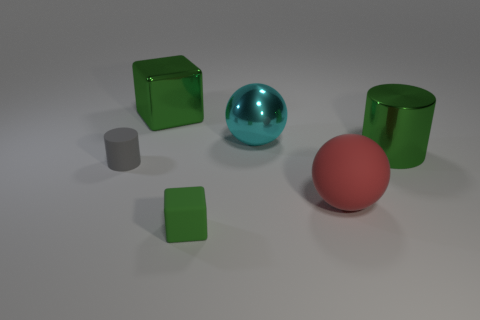Are there fewer big red things that are behind the green metallic cylinder than gray objects that are behind the tiny matte block?
Your answer should be very brief. Yes. What is the shape of the tiny thing to the right of the block behind the green matte cube?
Offer a very short reply. Cube. How many other things are made of the same material as the red thing?
Your response must be concise. 2. Is the number of red shiny spheres greater than the number of large metal spheres?
Your answer should be compact. No. There is a cylinder in front of the green metal object in front of the green object that is behind the big cyan sphere; what size is it?
Make the answer very short. Small. There is a green metallic cylinder; is it the same size as the green metallic thing on the left side of the green matte block?
Your answer should be compact. Yes. Are there fewer balls behind the large block than big brown shiny cylinders?
Offer a terse response. No. What number of other blocks are the same color as the big shiny block?
Offer a terse response. 1. Are there fewer red things than large green metal objects?
Provide a succinct answer. Yes. Does the red ball have the same material as the green cylinder?
Your answer should be very brief. No. 